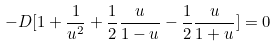Convert formula to latex. <formula><loc_0><loc_0><loc_500><loc_500>- D [ 1 + \frac { 1 } { u ^ { 2 } } + \frac { 1 } { 2 } \frac { u } { 1 - u } - \frac { 1 } { 2 } \frac { u } { 1 + u } ] = 0</formula> 